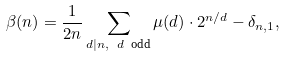Convert formula to latex. <formula><loc_0><loc_0><loc_500><loc_500>\beta ( n ) = \frac { 1 } { 2 n } \sum _ { d | n , \ d \ \text {odd} } \mu ( d ) \cdot 2 ^ { n / d } - \delta _ { n , 1 } ,</formula> 